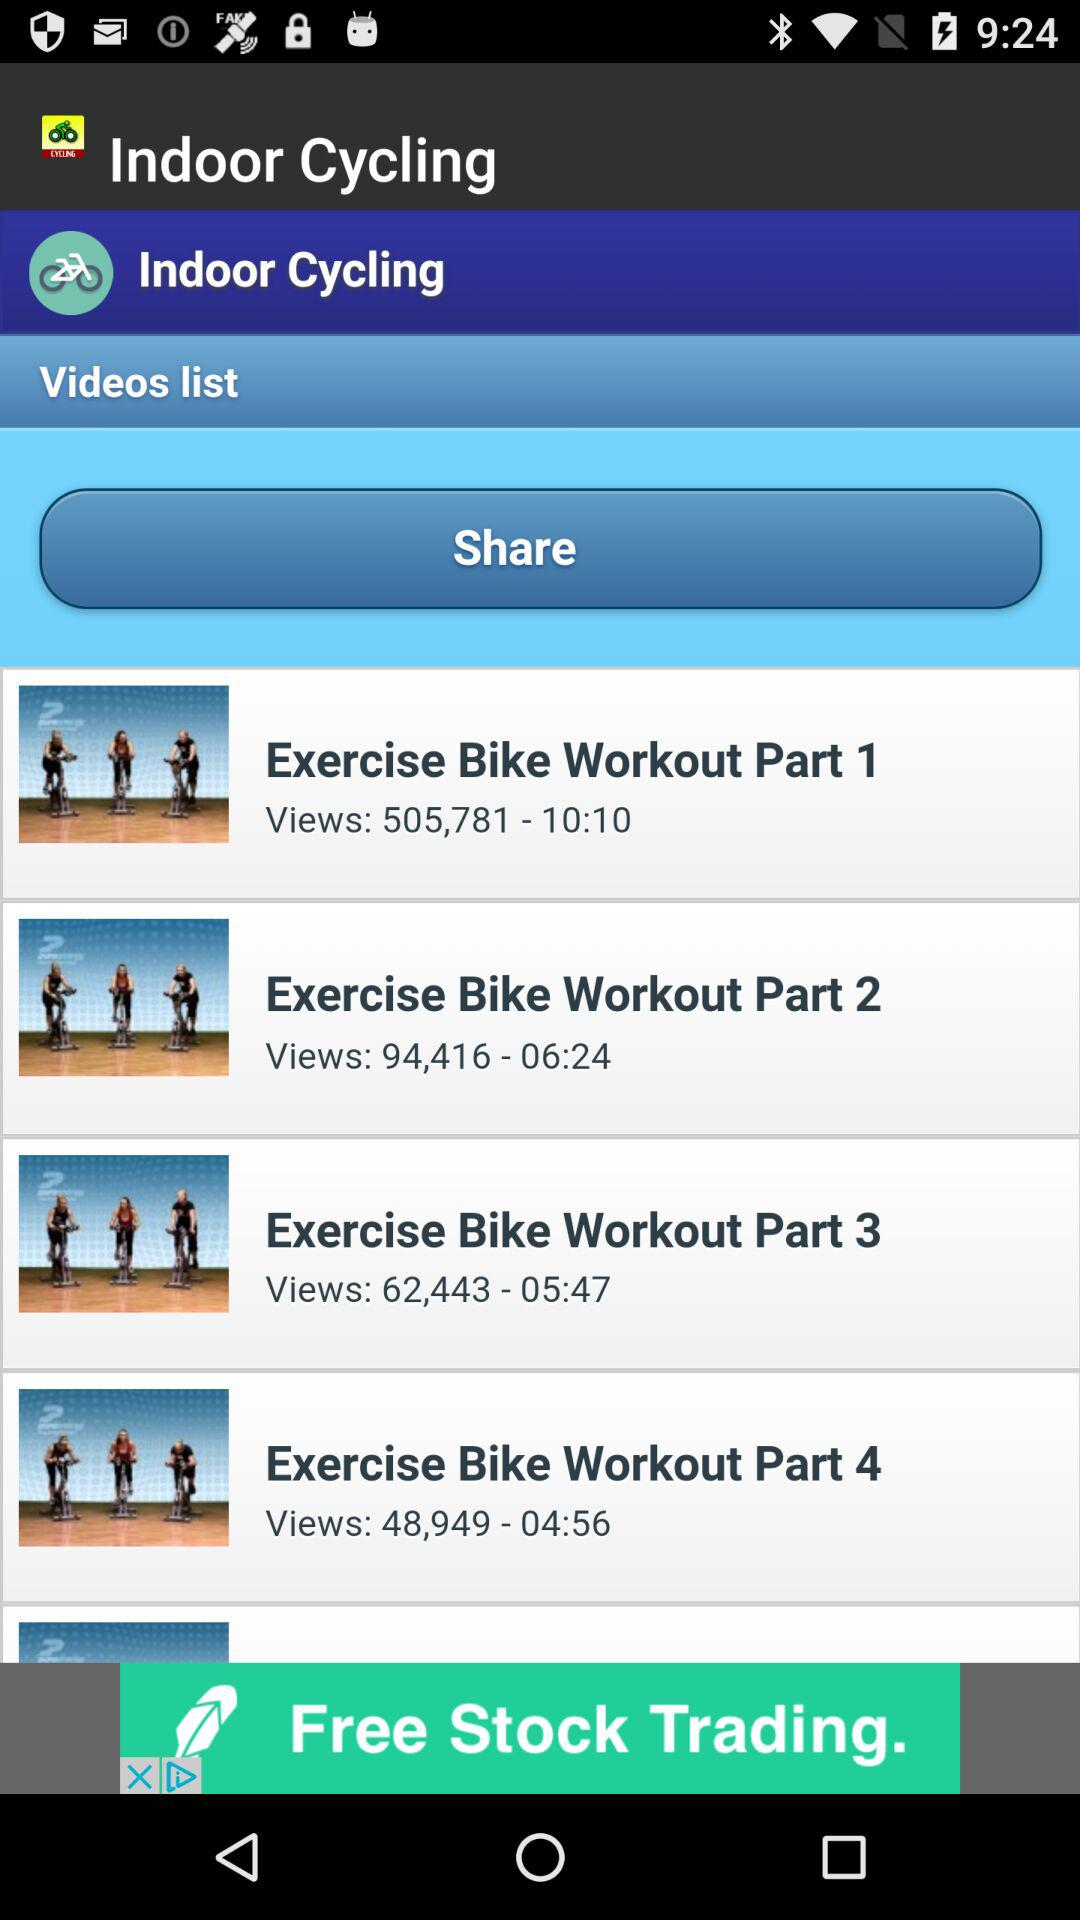What is the duration of the "Exercise Bike Workout Part 4" video? The duration of the "Exercise Bike Workout Part 4" video is 4 minutes 56 seconds. 